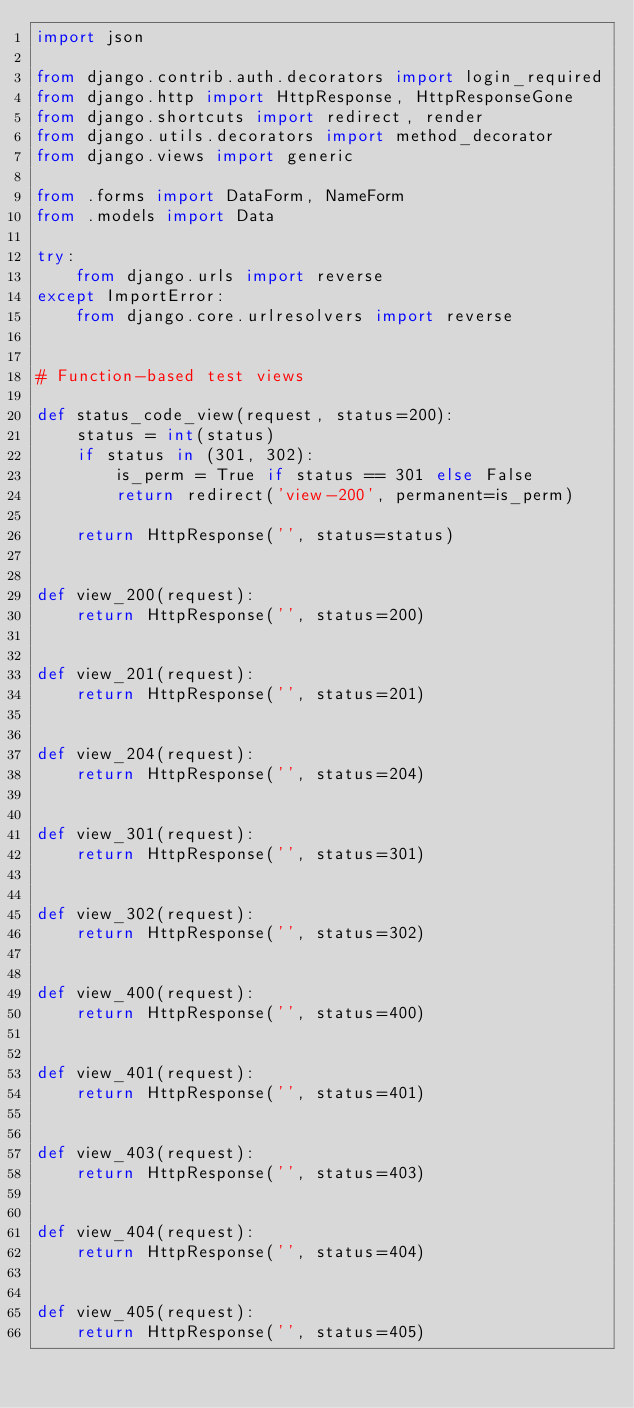Convert code to text. <code><loc_0><loc_0><loc_500><loc_500><_Python_>import json

from django.contrib.auth.decorators import login_required
from django.http import HttpResponse, HttpResponseGone
from django.shortcuts import redirect, render
from django.utils.decorators import method_decorator
from django.views import generic

from .forms import DataForm, NameForm
from .models import Data

try:
    from django.urls import reverse
except ImportError:
    from django.core.urlresolvers import reverse


# Function-based test views

def status_code_view(request, status=200):
    status = int(status)
    if status in (301, 302):
        is_perm = True if status == 301 else False
        return redirect('view-200', permanent=is_perm)

    return HttpResponse('', status=status)


def view_200(request):
    return HttpResponse('', status=200)


def view_201(request):
    return HttpResponse('', status=201)


def view_204(request):
    return HttpResponse('', status=204)


def view_301(request):
    return HttpResponse('', status=301)


def view_302(request):
    return HttpResponse('', status=302)


def view_400(request):
    return HttpResponse('', status=400)


def view_401(request):
    return HttpResponse('', status=401)


def view_403(request):
    return HttpResponse('', status=403)


def view_404(request):
    return HttpResponse('', status=404)


def view_405(request):
    return HttpResponse('', status=405)

</code> 